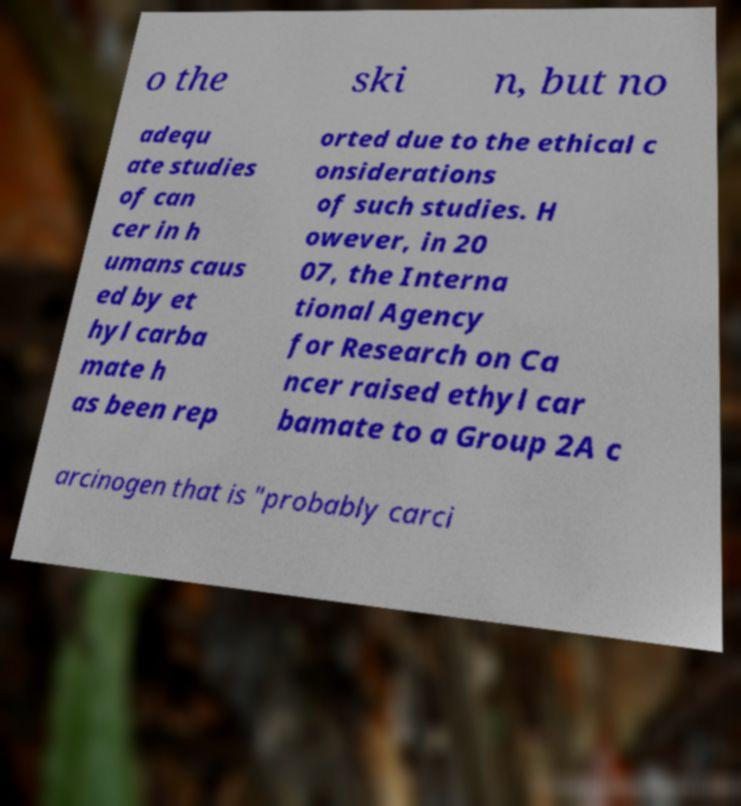For documentation purposes, I need the text within this image transcribed. Could you provide that? o the ski n, but no adequ ate studies of can cer in h umans caus ed by et hyl carba mate h as been rep orted due to the ethical c onsiderations of such studies. H owever, in 20 07, the Interna tional Agency for Research on Ca ncer raised ethyl car bamate to a Group 2A c arcinogen that is "probably carci 